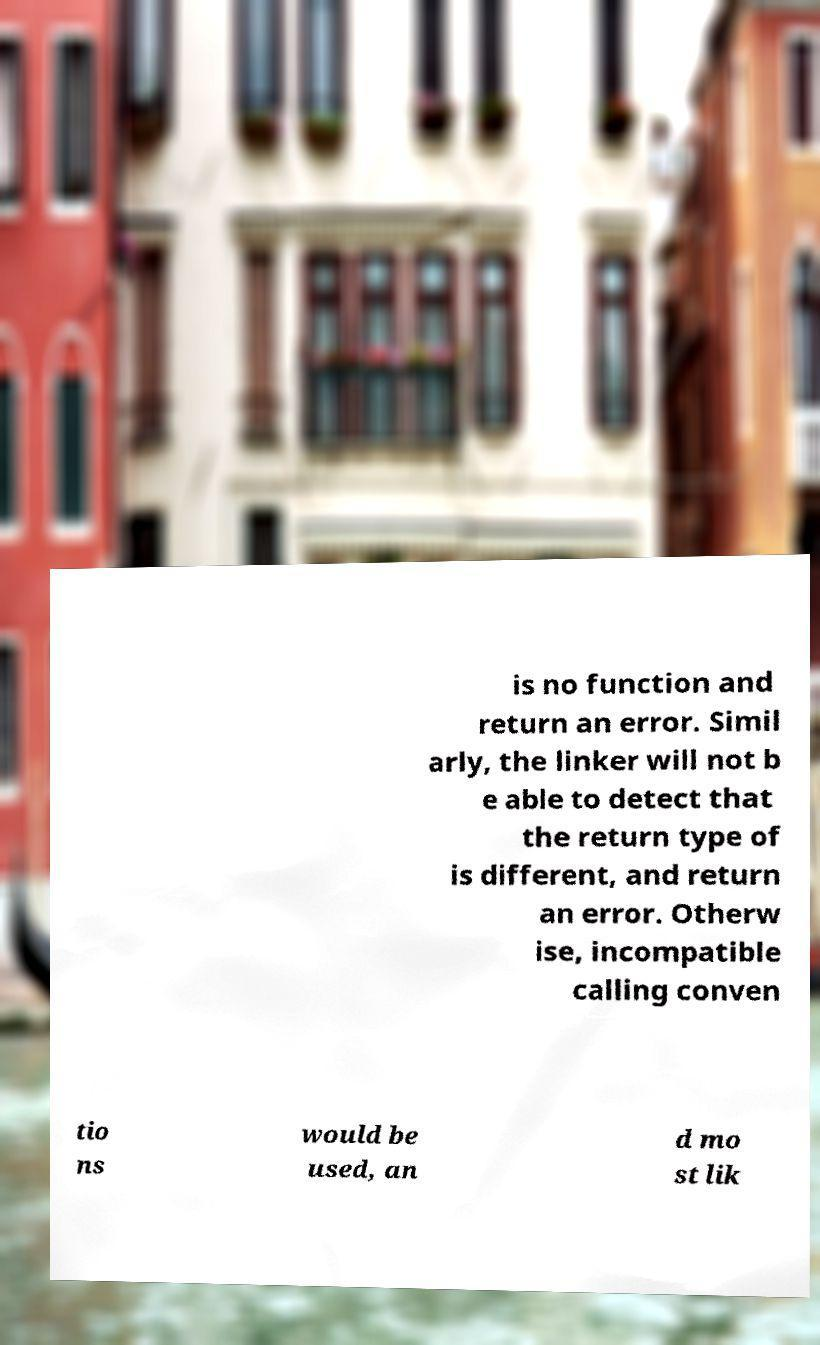Can you accurately transcribe the text from the provided image for me? is no function and return an error. Simil arly, the linker will not b e able to detect that the return type of is different, and return an error. Otherw ise, incompatible calling conven tio ns would be used, an d mo st lik 